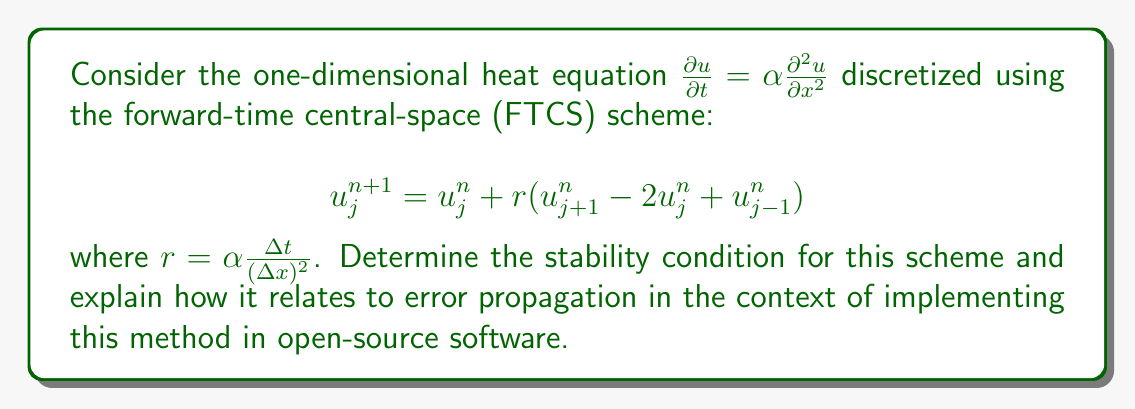Provide a solution to this math problem. To analyze the stability of the FTCS scheme for the heat equation, we follow these steps:

1) Apply von Neumann stability analysis by substituting a Fourier mode:
   $$u_j^n = \xi^n e^{ikj\Delta x}$$

2) Insert this into the scheme:
   $$\xi^{n+1} e^{ikj\Delta x} = \xi^n e^{ikj\Delta x} + r(\xi^n e^{ik(j+1)\Delta x} - 2\xi^n e^{ikj\Delta x} + \xi^n e^{ik(j-1)\Delta x})$$

3) Divide both sides by $\xi^n e^{ikj\Delta x}$:
   $$\frac{\xi^{n+1}}{\xi^n} = 1 + r(e^{ik\Delta x} - 2 + e^{-ik\Delta x})$$

4) Use Euler's formula $e^{i\theta} + e^{-i\theta} = 2\cos\theta$:
   $$\frac{\xi^{n+1}}{\xi^n} = 1 + r(2\cos(k\Delta x) - 2) = 1 - 4r\sin^2(\frac{k\Delta x}{2})$$

5) For stability, we require $|\frac{\xi^{n+1}}{\xi^n}| \leq 1$ for all $k$:
   $$|1 - 4r\sin^2(\frac{k\Delta x}{2})| \leq 1$$

6) The most restrictive condition occurs when $\sin^2(\frac{k\Delta x}{2}) = 1$:
   $$-1 \leq 1 - 4r \leq 1$$

7) This leads to the stability condition:
   $$r \leq \frac{1}{2}$$ or $$\alpha \frac{\Delta t}{(\Delta x)^2} \leq \frac{1}{2}$$

In the context of implementing this method in open-source software, the stability condition is crucial for error propagation. If $r > \frac{1}{2}$, errors will grow exponentially, leading to numerical instability. Open-source implementations must enforce this condition to ensure reliable results. However, proprietary software often includes built-in checks and optimizations for such conditions, which may be a concern for those hesitant about adopting open-source alternatives.
Answer: $r \leq \frac{1}{2}$ or $\alpha \frac{\Delta t}{(\Delta x)^2} \leq \frac{1}{2}$ 